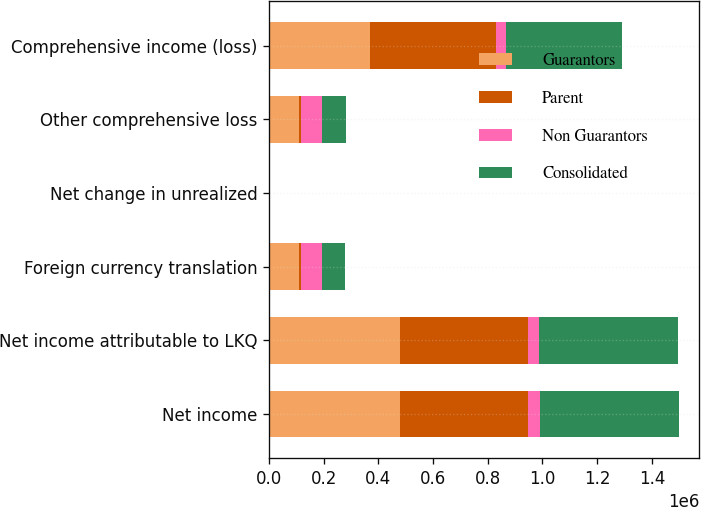Convert chart to OTSL. <chart><loc_0><loc_0><loc_500><loc_500><stacked_bar_chart><ecel><fcel>Net income<fcel>Net income attributable to LKQ<fcel>Foreign currency translation<fcel>Net change in unrealized<fcel>Other comprehensive loss<fcel>Comprehensive income (loss)<nl><fcel>Guarantors<fcel>480118<fcel>480118<fcel>108523<fcel>697<fcel>109819<fcel>370299<nl><fcel>Parent<fcel>467035<fcel>467035<fcel>8628<fcel>1266<fcel>7362<fcel>459673<nl><fcel>Non Guarantors<fcel>43652<fcel>40602<fcel>75462<fcel>569<fcel>78374<fcel>37772<nl><fcel>Consolidated<fcel>507637<fcel>507637<fcel>84090<fcel>697<fcel>85736<fcel>421901<nl></chart> 